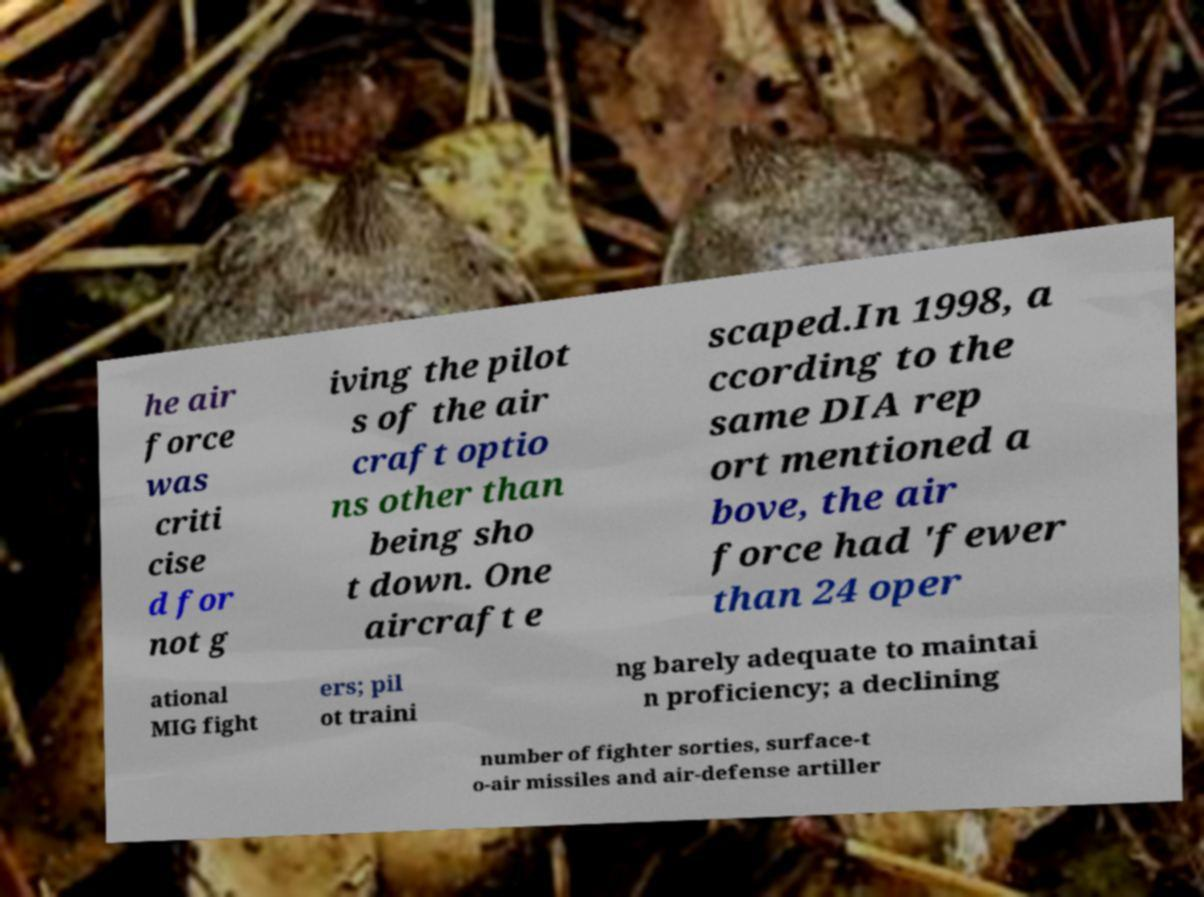Can you read and provide the text displayed in the image?This photo seems to have some interesting text. Can you extract and type it out for me? he air force was criti cise d for not g iving the pilot s of the air craft optio ns other than being sho t down. One aircraft e scaped.In 1998, a ccording to the same DIA rep ort mentioned a bove, the air force had 'fewer than 24 oper ational MIG fight ers; pil ot traini ng barely adequate to maintai n proficiency; a declining number of fighter sorties, surface-t o-air missiles and air-defense artiller 